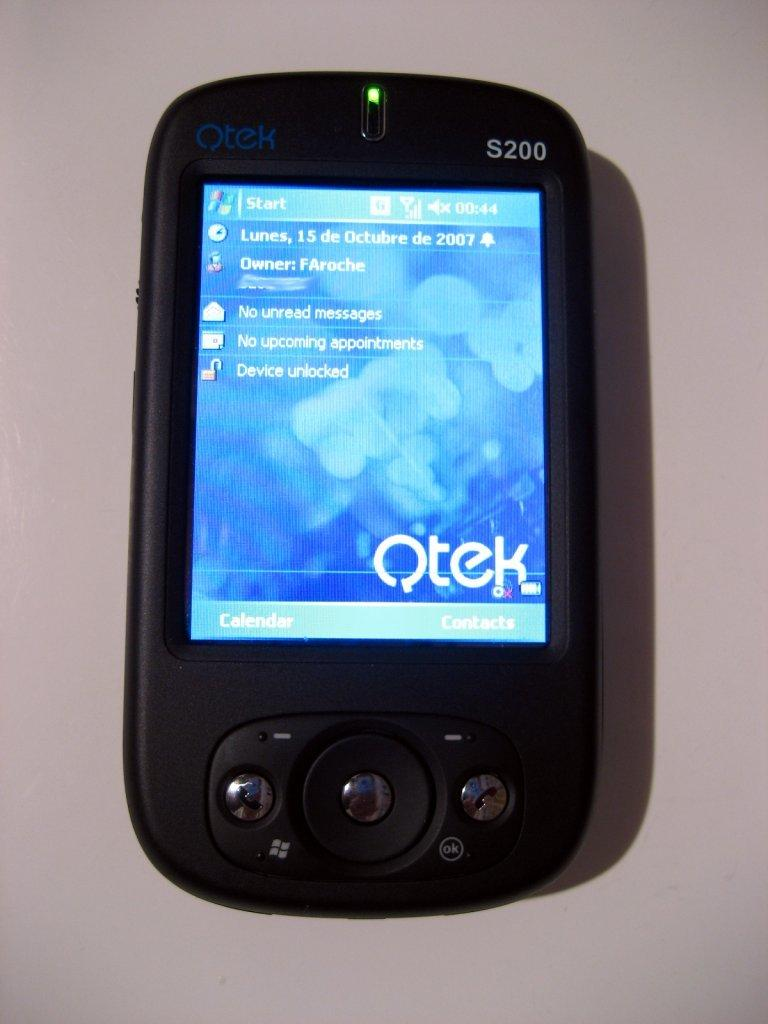<image>
Relay a brief, clear account of the picture shown. Small black phone modeled S200 showing the word QTEK on the screen. 